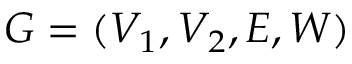Convert formula to latex. <formula><loc_0><loc_0><loc_500><loc_500>G = ( V _ { 1 } , V _ { 2 } , E , W )</formula> 